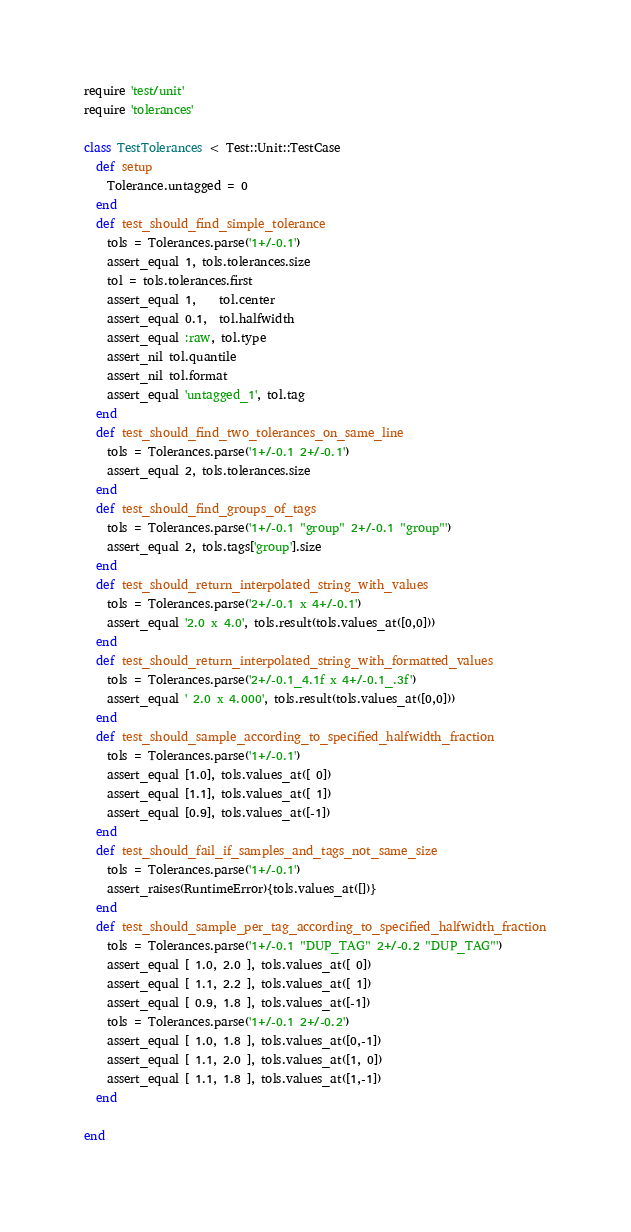Convert code to text. <code><loc_0><loc_0><loc_500><loc_500><_Ruby_>require 'test/unit'
require 'tolerances'

class TestTolerances < Test::Unit::TestCase
  def setup
    Tolerance.untagged = 0
  end
  def test_should_find_simple_tolerance
    tols = Tolerances.parse('1+/-0.1')
    assert_equal 1, tols.tolerances.size
    tol = tols.tolerances.first
    assert_equal 1,    tol.center
    assert_equal 0.1,  tol.halfwidth
    assert_equal :raw, tol.type
    assert_nil tol.quantile
    assert_nil tol.format
    assert_equal 'untagged_1', tol.tag
  end
  def test_should_find_two_tolerances_on_same_line
    tols = Tolerances.parse('1+/-0.1 2+/-0.1')
    assert_equal 2, tols.tolerances.size
  end
  def test_should_find_groups_of_tags
    tols = Tolerances.parse('1+/-0.1 "group" 2+/-0.1 "group"')
    assert_equal 2, tols.tags['group'].size
  end
  def test_should_return_interpolated_string_with_values
    tols = Tolerances.parse('2+/-0.1 x 4+/-0.1')
    assert_equal '2.0 x 4.0', tols.result(tols.values_at([0,0]))
  end
  def test_should_return_interpolated_string_with_formatted_values
    tols = Tolerances.parse('2+/-0.1_4.1f x 4+/-0.1_.3f')
    assert_equal ' 2.0 x 4.000', tols.result(tols.values_at([0,0]))
  end
  def test_should_sample_according_to_specified_halfwidth_fraction
    tols = Tolerances.parse('1+/-0.1')
    assert_equal [1.0], tols.values_at([ 0])
    assert_equal [1.1], tols.values_at([ 1])
    assert_equal [0.9], tols.values_at([-1])
  end
  def test_should_fail_if_samples_and_tags_not_same_size
    tols = Tolerances.parse('1+/-0.1')
    assert_raises(RuntimeError){tols.values_at([])}
  end
  def test_should_sample_per_tag_according_to_specified_halfwidth_fraction
    tols = Tolerances.parse('1+/-0.1 "DUP_TAG" 2+/-0.2 "DUP_TAG"')
    assert_equal [ 1.0, 2.0 ], tols.values_at([ 0])
    assert_equal [ 1.1, 2.2 ], tols.values_at([ 1])
    assert_equal [ 0.9, 1.8 ], tols.values_at([-1])
    tols = Tolerances.parse('1+/-0.1 2+/-0.2')
    assert_equal [ 1.0, 1.8 ], tols.values_at([0,-1])
    assert_equal [ 1.1, 2.0 ], tols.values_at([1, 0])
    assert_equal [ 1.1, 1.8 ], tols.values_at([1,-1])
  end

end
</code> 